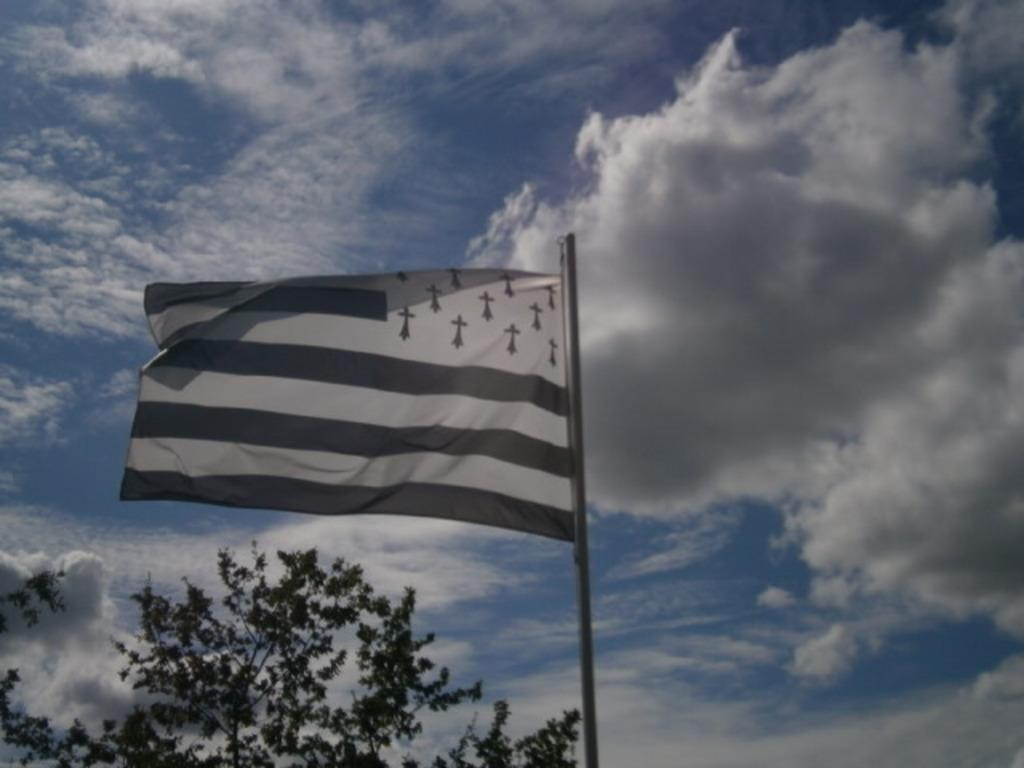What is the main subject in the center of the image? There is a flag in the center of the image. What other object can be seen at the bottom side of the image? There is a tree at the bottom side of the image. What can be seen in the background of the image? The sky is visible in the background of the image. What type of bag is hanging from the tree in the image? There is no bag present in the image; it only features a flag and a tree. Can you describe the head of the dog in the image? There is no dog present in the image, so it is not possible to describe its head. 